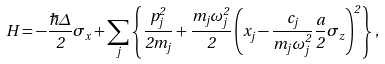Convert formula to latex. <formula><loc_0><loc_0><loc_500><loc_500>H = - \frac { \hbar { \Delta } } { 2 } \sigma _ { x } + \sum _ { j } \left \{ \frac { p _ { j } ^ { 2 } } { 2 m _ { j } } + \frac { m _ { j } \omega _ { j } ^ { 2 } } { 2 } \left ( x _ { j } - \frac { c _ { j } } { m _ { j } \omega _ { j } ^ { 2 } } \frac { a } { 2 } \sigma _ { z } \right ) ^ { 2 } \right \} ,</formula> 